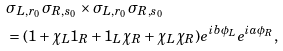<formula> <loc_0><loc_0><loc_500><loc_500>& \sigma _ { L , r _ { 0 } } \sigma _ { R , s _ { 0 } } \times \sigma _ { L , r _ { 0 } } \sigma _ { R , s _ { 0 } } \\ & = ( 1 + \chi _ { L } 1 _ { R } + 1 _ { L } \chi _ { R } + \chi _ { L } \chi _ { R } ) e ^ { i b \phi _ { L } } e ^ { i a \phi _ { R } } ,</formula> 